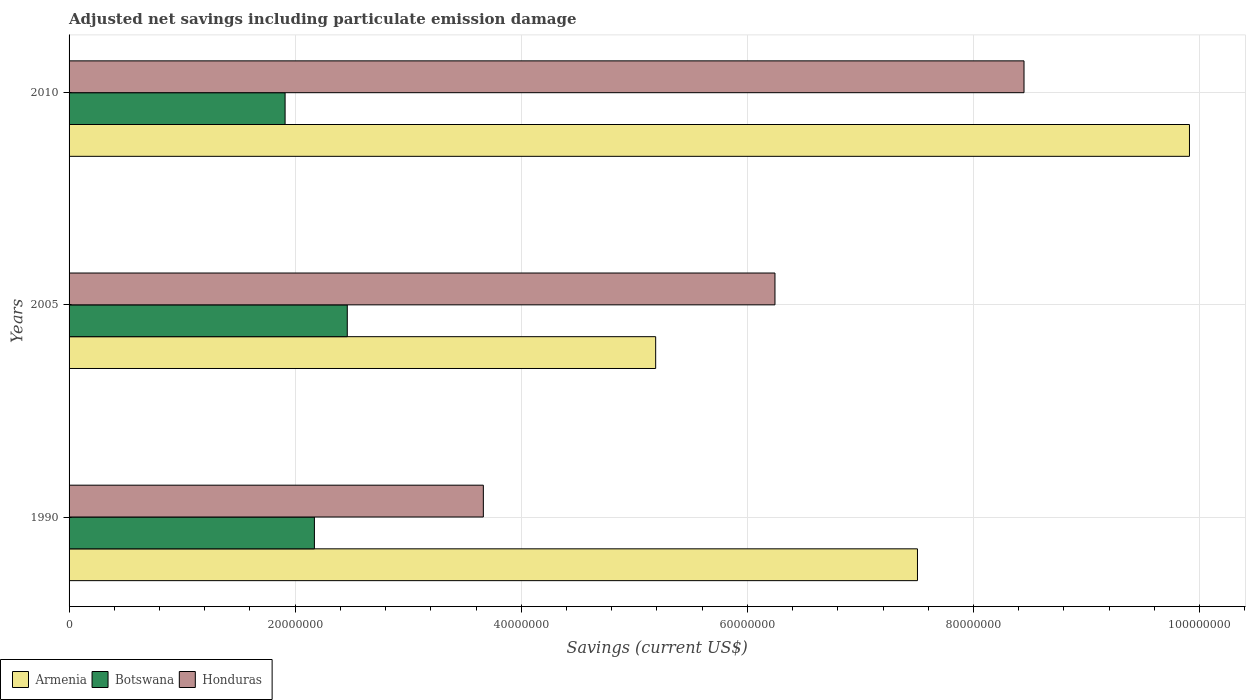How many groups of bars are there?
Keep it short and to the point. 3. Are the number of bars on each tick of the Y-axis equal?
Give a very brief answer. Yes. What is the label of the 2nd group of bars from the top?
Offer a very short reply. 2005. What is the net savings in Honduras in 1990?
Offer a very short reply. 3.66e+07. Across all years, what is the maximum net savings in Armenia?
Keep it short and to the point. 9.91e+07. Across all years, what is the minimum net savings in Armenia?
Provide a short and direct response. 5.19e+07. In which year was the net savings in Armenia maximum?
Offer a terse response. 2010. What is the total net savings in Botswana in the graph?
Your response must be concise. 6.54e+07. What is the difference between the net savings in Honduras in 1990 and that in 2010?
Give a very brief answer. -4.78e+07. What is the difference between the net savings in Armenia in 1990 and the net savings in Botswana in 2005?
Make the answer very short. 5.04e+07. What is the average net savings in Honduras per year?
Offer a very short reply. 6.12e+07. In the year 2005, what is the difference between the net savings in Honduras and net savings in Botswana?
Offer a very short reply. 3.78e+07. In how many years, is the net savings in Honduras greater than 36000000 US$?
Your answer should be very brief. 3. What is the ratio of the net savings in Honduras in 1990 to that in 2010?
Your response must be concise. 0.43. Is the net savings in Armenia in 1990 less than that in 2005?
Make the answer very short. No. Is the difference between the net savings in Honduras in 1990 and 2005 greater than the difference between the net savings in Botswana in 1990 and 2005?
Provide a succinct answer. No. What is the difference between the highest and the second highest net savings in Botswana?
Offer a very short reply. 2.91e+06. What is the difference between the highest and the lowest net savings in Honduras?
Offer a very short reply. 4.78e+07. Is the sum of the net savings in Botswana in 2005 and 2010 greater than the maximum net savings in Honduras across all years?
Provide a succinct answer. No. What does the 2nd bar from the top in 2010 represents?
Offer a terse response. Botswana. What does the 3rd bar from the bottom in 2010 represents?
Ensure brevity in your answer.  Honduras. How many bars are there?
Keep it short and to the point. 9. What is the difference between two consecutive major ticks on the X-axis?
Provide a short and direct response. 2.00e+07. Does the graph contain any zero values?
Ensure brevity in your answer.  No. How many legend labels are there?
Offer a terse response. 3. How are the legend labels stacked?
Your answer should be very brief. Horizontal. What is the title of the graph?
Provide a succinct answer. Adjusted net savings including particulate emission damage. Does "Niger" appear as one of the legend labels in the graph?
Ensure brevity in your answer.  No. What is the label or title of the X-axis?
Offer a terse response. Savings (current US$). What is the label or title of the Y-axis?
Your answer should be very brief. Years. What is the Savings (current US$) in Armenia in 1990?
Provide a succinct answer. 7.50e+07. What is the Savings (current US$) of Botswana in 1990?
Make the answer very short. 2.17e+07. What is the Savings (current US$) in Honduras in 1990?
Offer a terse response. 3.66e+07. What is the Savings (current US$) in Armenia in 2005?
Your answer should be very brief. 5.19e+07. What is the Savings (current US$) in Botswana in 2005?
Ensure brevity in your answer.  2.46e+07. What is the Savings (current US$) in Honduras in 2005?
Ensure brevity in your answer.  6.24e+07. What is the Savings (current US$) in Armenia in 2010?
Ensure brevity in your answer.  9.91e+07. What is the Savings (current US$) of Botswana in 2010?
Your answer should be compact. 1.91e+07. What is the Savings (current US$) of Honduras in 2010?
Offer a very short reply. 8.45e+07. Across all years, what is the maximum Savings (current US$) in Armenia?
Keep it short and to the point. 9.91e+07. Across all years, what is the maximum Savings (current US$) in Botswana?
Ensure brevity in your answer.  2.46e+07. Across all years, what is the maximum Savings (current US$) of Honduras?
Your answer should be very brief. 8.45e+07. Across all years, what is the minimum Savings (current US$) in Armenia?
Offer a terse response. 5.19e+07. Across all years, what is the minimum Savings (current US$) in Botswana?
Your answer should be compact. 1.91e+07. Across all years, what is the minimum Savings (current US$) in Honduras?
Provide a short and direct response. 3.66e+07. What is the total Savings (current US$) of Armenia in the graph?
Offer a terse response. 2.26e+08. What is the total Savings (current US$) in Botswana in the graph?
Keep it short and to the point. 6.54e+07. What is the total Savings (current US$) in Honduras in the graph?
Provide a succinct answer. 1.84e+08. What is the difference between the Savings (current US$) in Armenia in 1990 and that in 2005?
Offer a terse response. 2.32e+07. What is the difference between the Savings (current US$) of Botswana in 1990 and that in 2005?
Make the answer very short. -2.91e+06. What is the difference between the Savings (current US$) of Honduras in 1990 and that in 2005?
Provide a succinct answer. -2.58e+07. What is the difference between the Savings (current US$) of Armenia in 1990 and that in 2010?
Your answer should be compact. -2.41e+07. What is the difference between the Savings (current US$) of Botswana in 1990 and that in 2010?
Offer a terse response. 2.59e+06. What is the difference between the Savings (current US$) in Honduras in 1990 and that in 2010?
Offer a very short reply. -4.78e+07. What is the difference between the Savings (current US$) in Armenia in 2005 and that in 2010?
Provide a short and direct response. -4.72e+07. What is the difference between the Savings (current US$) in Botswana in 2005 and that in 2010?
Give a very brief answer. 5.50e+06. What is the difference between the Savings (current US$) in Honduras in 2005 and that in 2010?
Your answer should be compact. -2.20e+07. What is the difference between the Savings (current US$) of Armenia in 1990 and the Savings (current US$) of Botswana in 2005?
Your answer should be very brief. 5.04e+07. What is the difference between the Savings (current US$) in Armenia in 1990 and the Savings (current US$) in Honduras in 2005?
Give a very brief answer. 1.26e+07. What is the difference between the Savings (current US$) of Botswana in 1990 and the Savings (current US$) of Honduras in 2005?
Offer a very short reply. -4.07e+07. What is the difference between the Savings (current US$) in Armenia in 1990 and the Savings (current US$) in Botswana in 2010?
Ensure brevity in your answer.  5.59e+07. What is the difference between the Savings (current US$) in Armenia in 1990 and the Savings (current US$) in Honduras in 2010?
Your answer should be compact. -9.42e+06. What is the difference between the Savings (current US$) of Botswana in 1990 and the Savings (current US$) of Honduras in 2010?
Keep it short and to the point. -6.28e+07. What is the difference between the Savings (current US$) of Armenia in 2005 and the Savings (current US$) of Botswana in 2010?
Keep it short and to the point. 3.28e+07. What is the difference between the Savings (current US$) of Armenia in 2005 and the Savings (current US$) of Honduras in 2010?
Ensure brevity in your answer.  -3.26e+07. What is the difference between the Savings (current US$) in Botswana in 2005 and the Savings (current US$) in Honduras in 2010?
Provide a succinct answer. -5.99e+07. What is the average Savings (current US$) of Armenia per year?
Keep it short and to the point. 7.53e+07. What is the average Savings (current US$) of Botswana per year?
Provide a succinct answer. 2.18e+07. What is the average Savings (current US$) in Honduras per year?
Offer a very short reply. 6.12e+07. In the year 1990, what is the difference between the Savings (current US$) in Armenia and Savings (current US$) in Botswana?
Keep it short and to the point. 5.33e+07. In the year 1990, what is the difference between the Savings (current US$) of Armenia and Savings (current US$) of Honduras?
Ensure brevity in your answer.  3.84e+07. In the year 1990, what is the difference between the Savings (current US$) in Botswana and Savings (current US$) in Honduras?
Make the answer very short. -1.49e+07. In the year 2005, what is the difference between the Savings (current US$) in Armenia and Savings (current US$) in Botswana?
Your answer should be very brief. 2.73e+07. In the year 2005, what is the difference between the Savings (current US$) of Armenia and Savings (current US$) of Honduras?
Provide a short and direct response. -1.06e+07. In the year 2005, what is the difference between the Savings (current US$) in Botswana and Savings (current US$) in Honduras?
Your answer should be compact. -3.78e+07. In the year 2010, what is the difference between the Savings (current US$) of Armenia and Savings (current US$) of Botswana?
Your answer should be compact. 8.00e+07. In the year 2010, what is the difference between the Savings (current US$) of Armenia and Savings (current US$) of Honduras?
Provide a succinct answer. 1.46e+07. In the year 2010, what is the difference between the Savings (current US$) in Botswana and Savings (current US$) in Honduras?
Give a very brief answer. -6.54e+07. What is the ratio of the Savings (current US$) in Armenia in 1990 to that in 2005?
Make the answer very short. 1.45. What is the ratio of the Savings (current US$) of Botswana in 1990 to that in 2005?
Provide a succinct answer. 0.88. What is the ratio of the Savings (current US$) of Honduras in 1990 to that in 2005?
Provide a succinct answer. 0.59. What is the ratio of the Savings (current US$) in Armenia in 1990 to that in 2010?
Make the answer very short. 0.76. What is the ratio of the Savings (current US$) in Botswana in 1990 to that in 2010?
Your answer should be compact. 1.14. What is the ratio of the Savings (current US$) in Honduras in 1990 to that in 2010?
Make the answer very short. 0.43. What is the ratio of the Savings (current US$) in Armenia in 2005 to that in 2010?
Make the answer very short. 0.52. What is the ratio of the Savings (current US$) in Botswana in 2005 to that in 2010?
Provide a succinct answer. 1.29. What is the ratio of the Savings (current US$) in Honduras in 2005 to that in 2010?
Offer a very short reply. 0.74. What is the difference between the highest and the second highest Savings (current US$) in Armenia?
Provide a succinct answer. 2.41e+07. What is the difference between the highest and the second highest Savings (current US$) in Botswana?
Your answer should be very brief. 2.91e+06. What is the difference between the highest and the second highest Savings (current US$) in Honduras?
Keep it short and to the point. 2.20e+07. What is the difference between the highest and the lowest Savings (current US$) of Armenia?
Your answer should be compact. 4.72e+07. What is the difference between the highest and the lowest Savings (current US$) in Botswana?
Provide a short and direct response. 5.50e+06. What is the difference between the highest and the lowest Savings (current US$) in Honduras?
Offer a very short reply. 4.78e+07. 